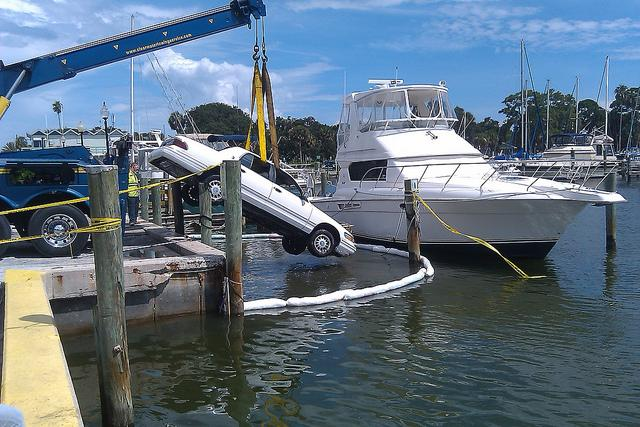Where has the white car on the yellow straps been? water 